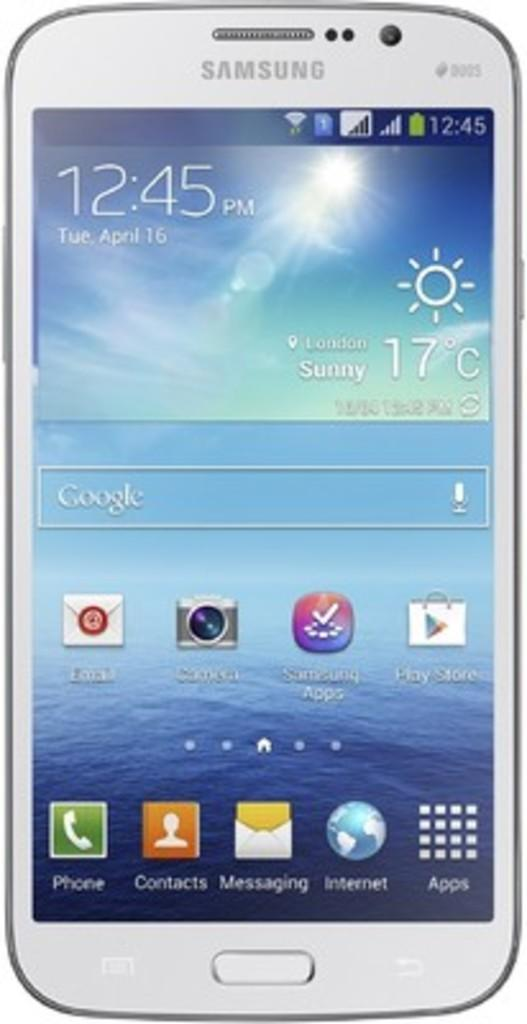<image>
Present a compact description of the photo's key features. a phone that has the time of 12:45 on it 